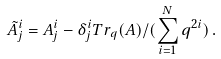Convert formula to latex. <formula><loc_0><loc_0><loc_500><loc_500>\tilde { A } ^ { i } _ { j } = A ^ { i } _ { j } - \delta ^ { i } _ { j } T r _ { q } ( A ) / ( \sum _ { i = 1 } ^ { N } q ^ { 2 i } ) \, .</formula> 